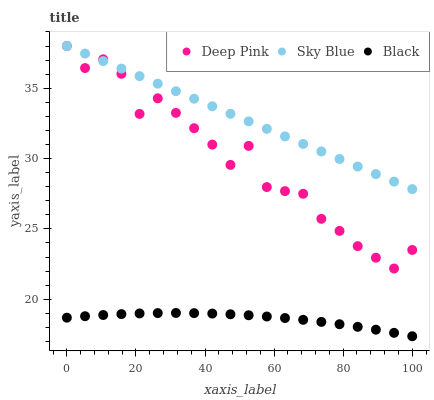Does Black have the minimum area under the curve?
Answer yes or no. Yes. Does Sky Blue have the maximum area under the curve?
Answer yes or no. Yes. Does Deep Pink have the minimum area under the curve?
Answer yes or no. No. Does Deep Pink have the maximum area under the curve?
Answer yes or no. No. Is Sky Blue the smoothest?
Answer yes or no. Yes. Is Deep Pink the roughest?
Answer yes or no. Yes. Is Black the smoothest?
Answer yes or no. No. Is Black the roughest?
Answer yes or no. No. Does Black have the lowest value?
Answer yes or no. Yes. Does Deep Pink have the lowest value?
Answer yes or no. No. Does Deep Pink have the highest value?
Answer yes or no. Yes. Does Black have the highest value?
Answer yes or no. No. Is Black less than Deep Pink?
Answer yes or no. Yes. Is Sky Blue greater than Black?
Answer yes or no. Yes. Does Sky Blue intersect Deep Pink?
Answer yes or no. Yes. Is Sky Blue less than Deep Pink?
Answer yes or no. No. Is Sky Blue greater than Deep Pink?
Answer yes or no. No. Does Black intersect Deep Pink?
Answer yes or no. No. 